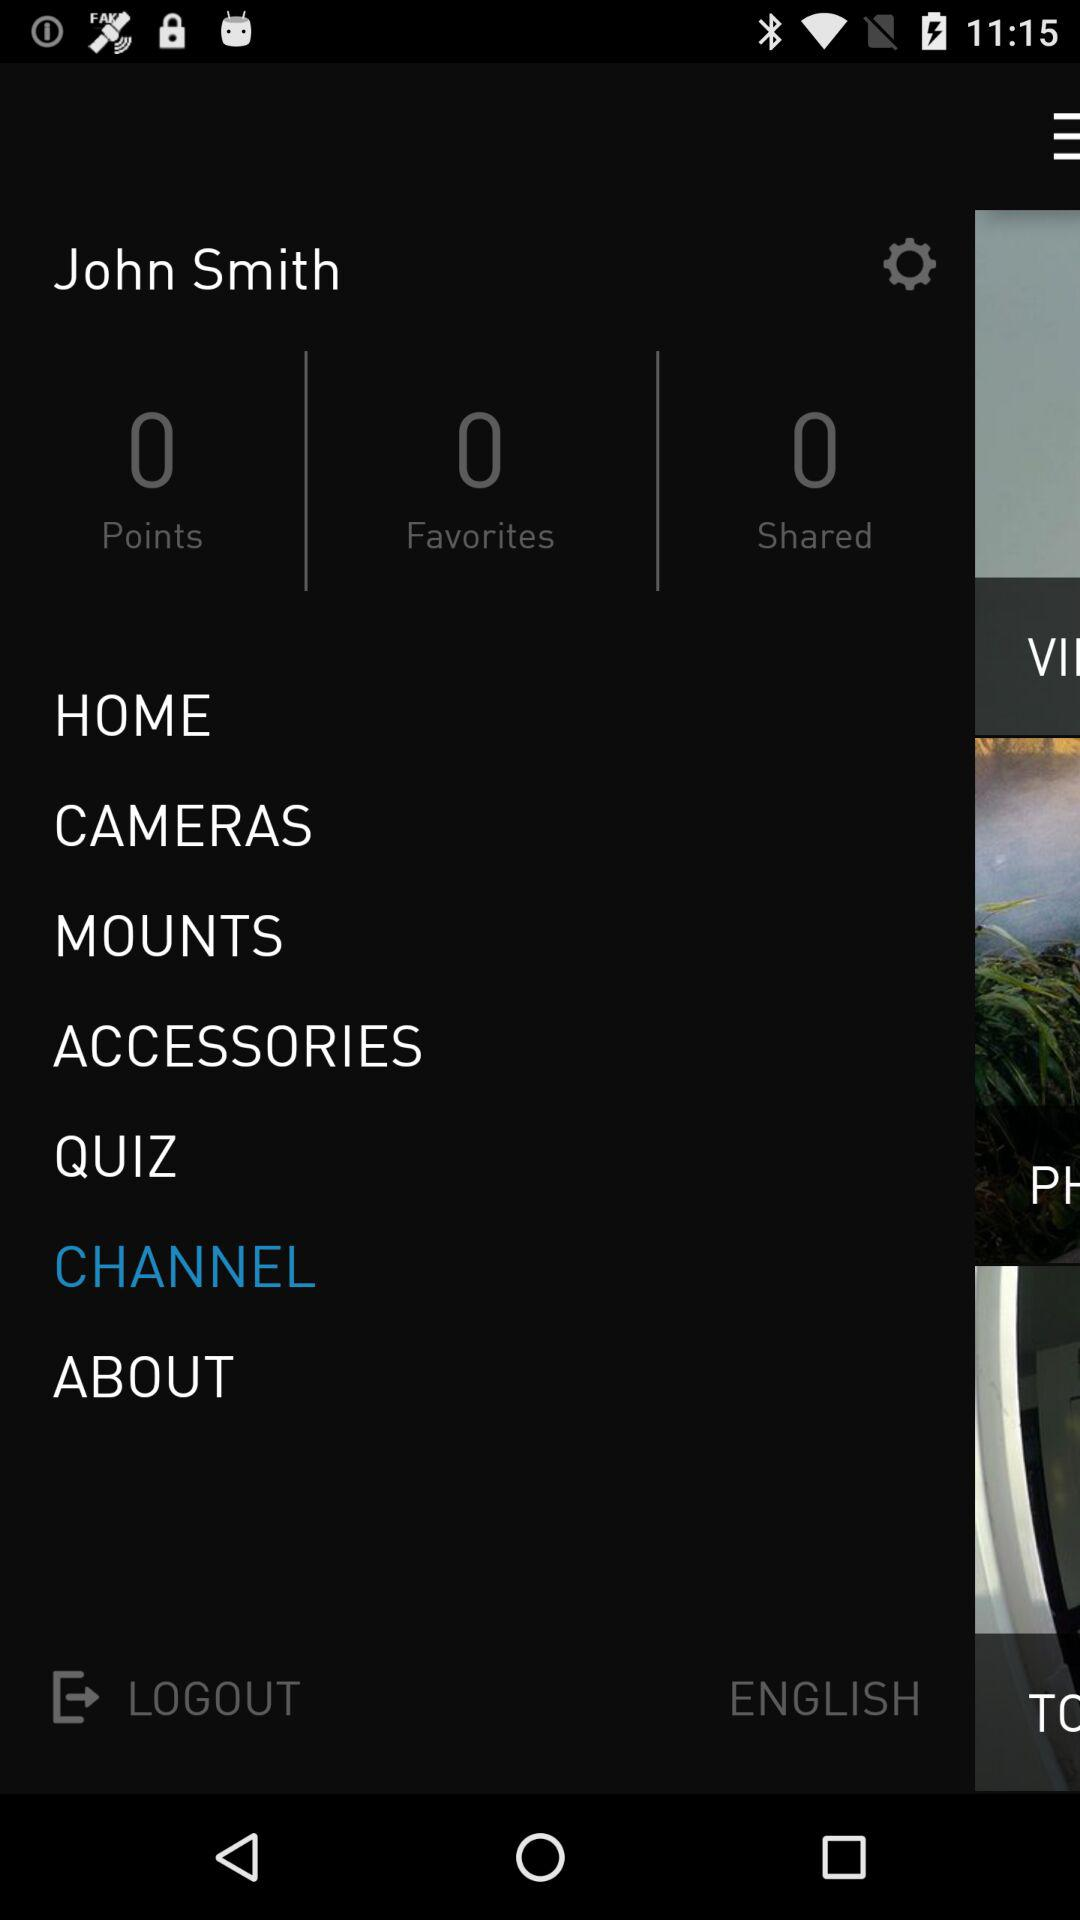What is the user name? The user name is John Smith. 